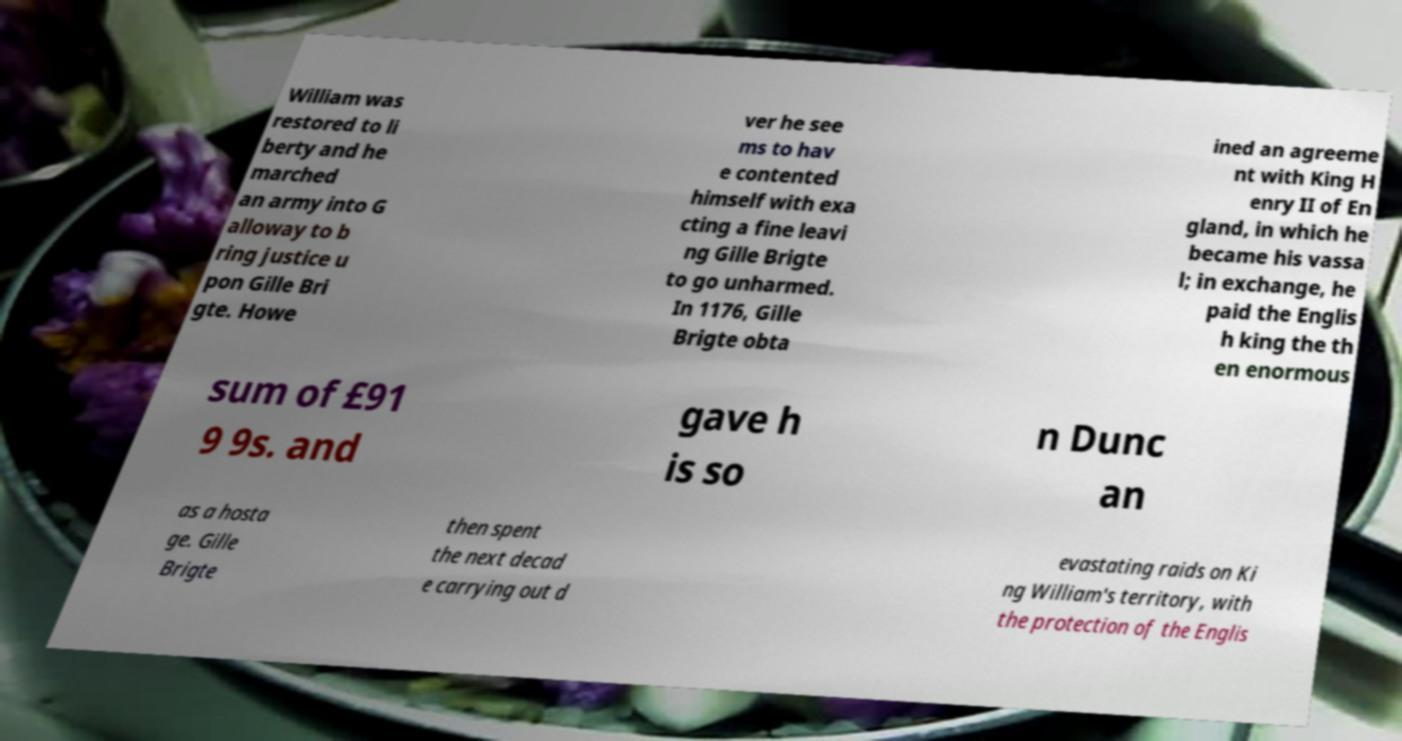For documentation purposes, I need the text within this image transcribed. Could you provide that? William was restored to li berty and he marched an army into G alloway to b ring justice u pon Gille Bri gte. Howe ver he see ms to hav e contented himself with exa cting a fine leavi ng Gille Brigte to go unharmed. In 1176, Gille Brigte obta ined an agreeme nt with King H enry II of En gland, in which he became his vassa l; in exchange, he paid the Englis h king the th en enormous sum of £91 9 9s. and gave h is so n Dunc an as a hosta ge. Gille Brigte then spent the next decad e carrying out d evastating raids on Ki ng William's territory, with the protection of the Englis 